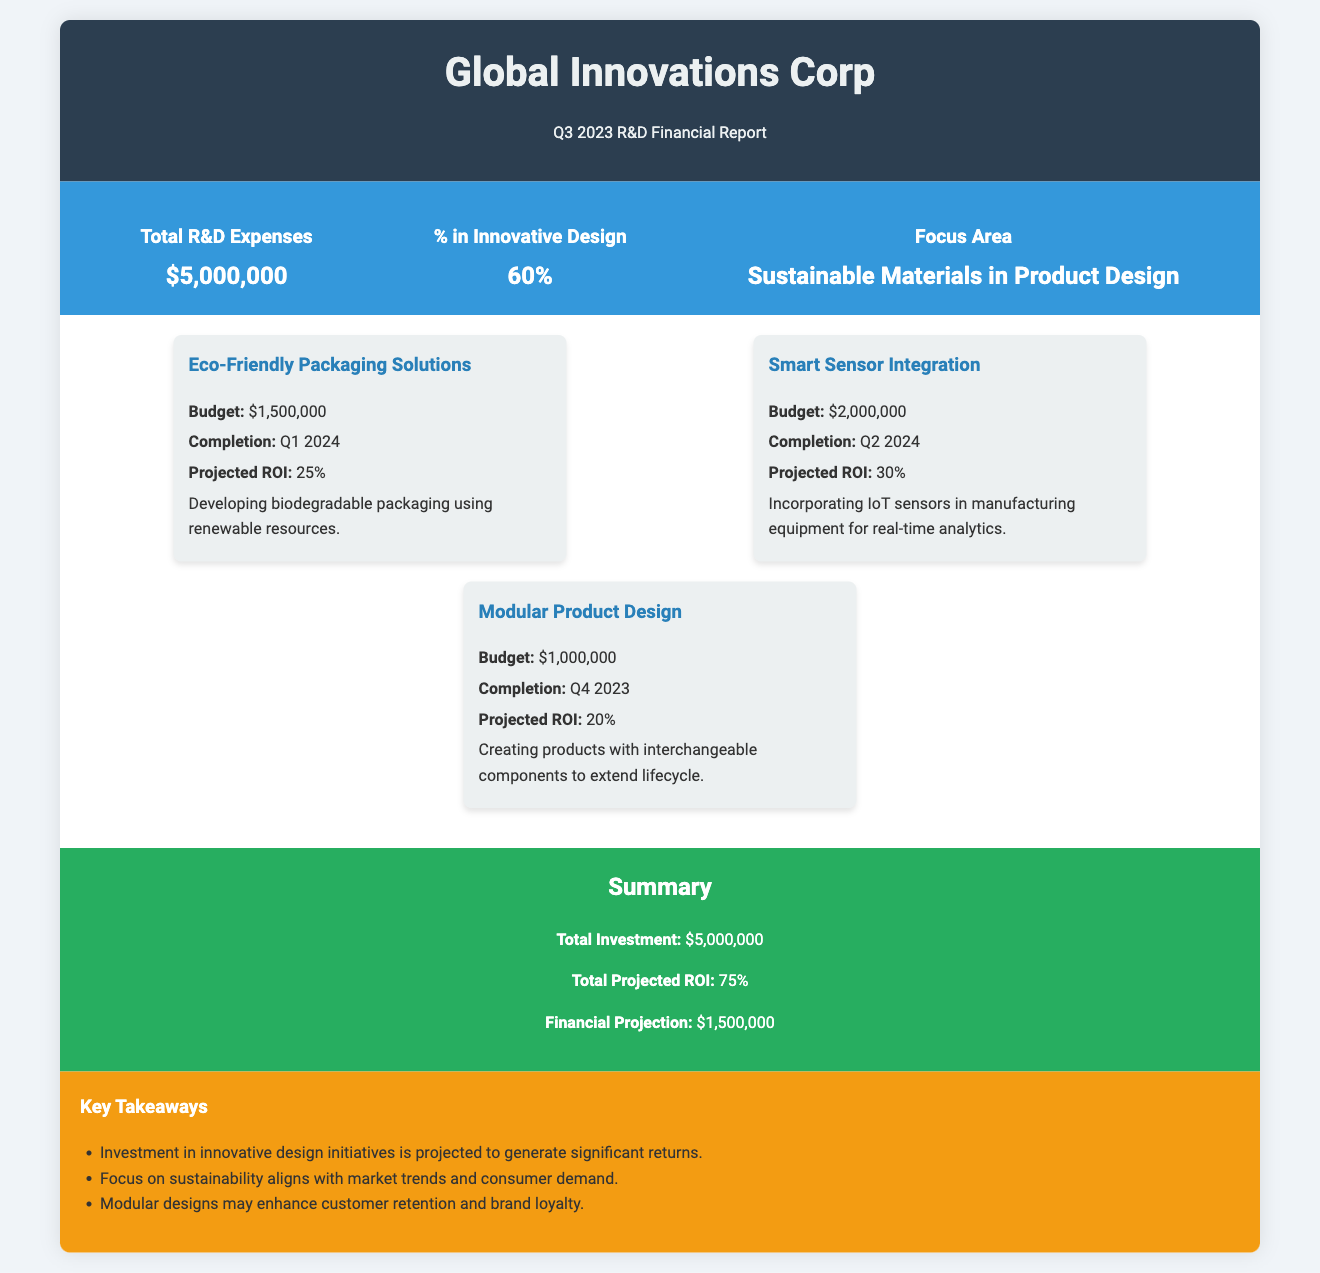What are the total R&D expenses? The total R&D expenses are highlighted clearly in the overview section of the report.
Answer: $5,000,000 What percentage of R&D is allocated to innovative design? This information is provided in the overview section, which indicates the focus on innovative design initiatives.
Answer: 60% What is the focus area of the R&D expenses? The focus area is mentioned in the overview section of the report, identifying the theme of the initiatives.
Answer: Sustainable Materials in Product Design What is the budget for Eco-Friendly Packaging Solutions? The budget for this initiative is stated in the details provided under each initiative in the report.
Answer: $1,500,000 What is the projected ROI for Smart Sensor Integration? The projected ROI is provided next to the initiative, allowing for quick comparison between different initiatives.
Answer: 30% When is the completion date for Modular Product Design? The completion date for each initiative is specified in the details of that initiative in the report.
Answer: Q4 2023 What is the total projected ROI from all initiatives combined? The report summarizes the total projected ROI at the end of the initiatives section.
Answer: 75% What is the financial projection based on the R&D expenses? This figure is given in the summary section, capturing the expected financial returns from the investment.
Answer: $1,500,000 What key takeaway mentions market trends? One of the key takeaways emphasizes the alignment of the company's focus on sustainability with consumer demand.
Answer: Investment in innovative design initiatives is projected to generate significant returns 